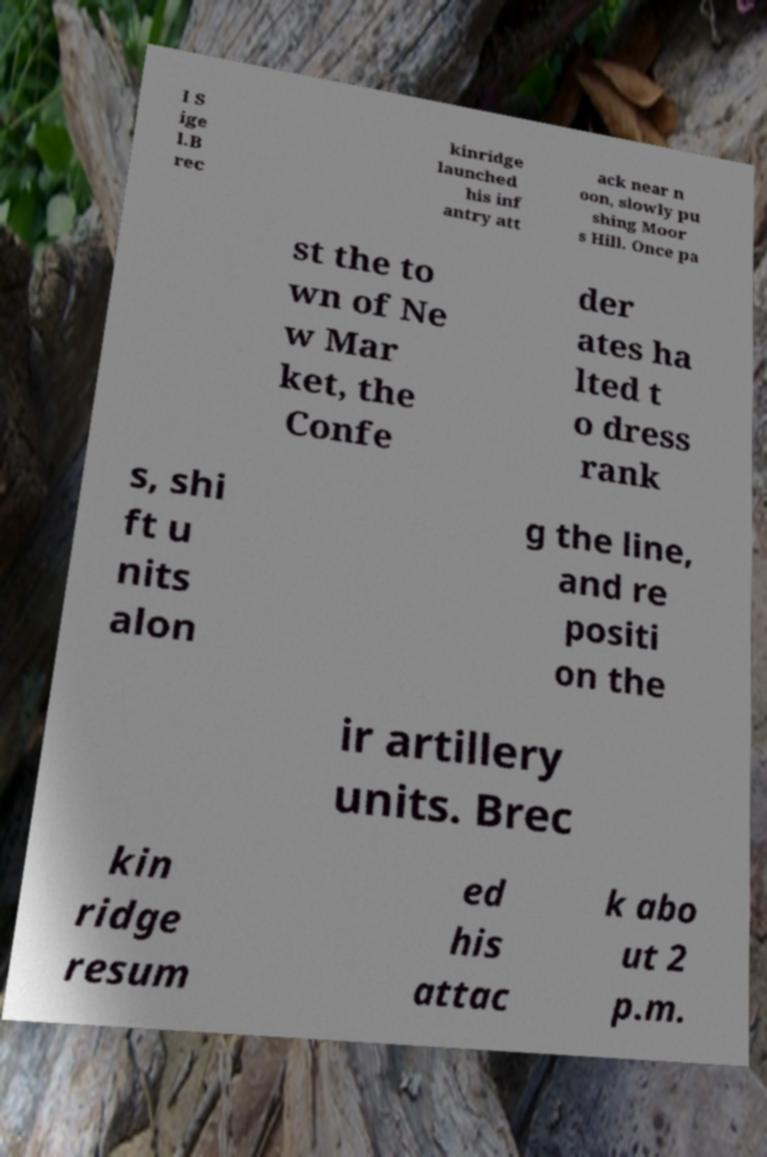There's text embedded in this image that I need extracted. Can you transcribe it verbatim? l S ige l.B rec kinridge launched his inf antry att ack near n oon, slowly pu shing Moor s Hill. Once pa st the to wn of Ne w Mar ket, the Confe der ates ha lted t o dress rank s, shi ft u nits alon g the line, and re positi on the ir artillery units. Brec kin ridge resum ed his attac k abo ut 2 p.m. 